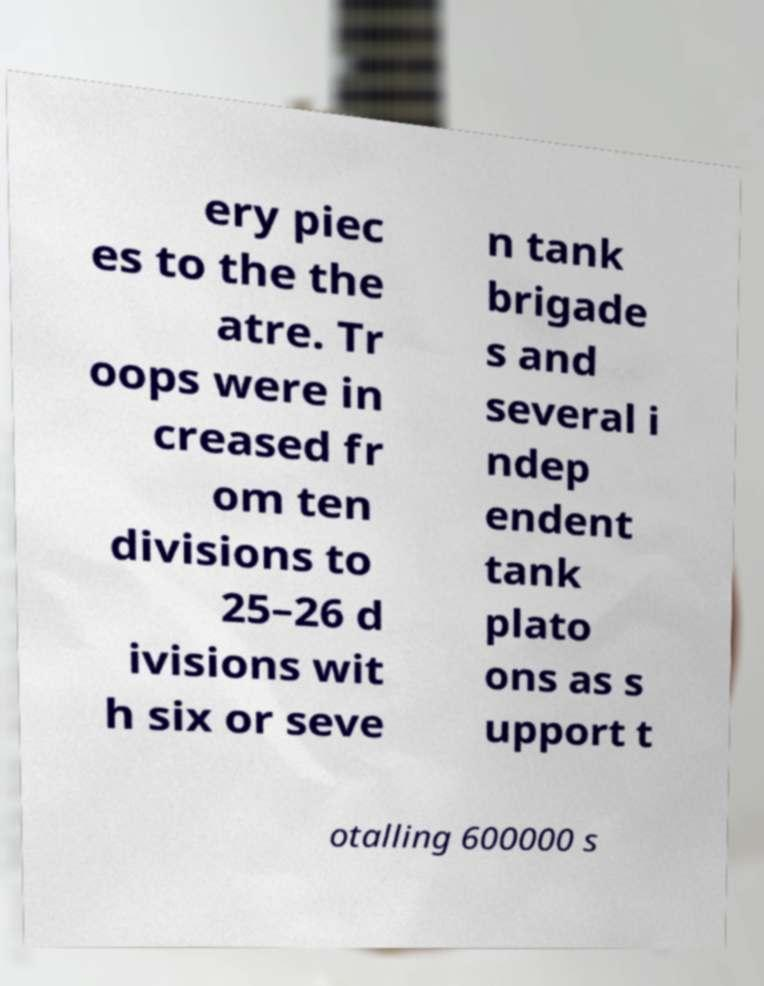Can you accurately transcribe the text from the provided image for me? ery piec es to the the atre. Tr oops were in creased fr om ten divisions to 25–26 d ivisions wit h six or seve n tank brigade s and several i ndep endent tank plato ons as s upport t otalling 600000 s 